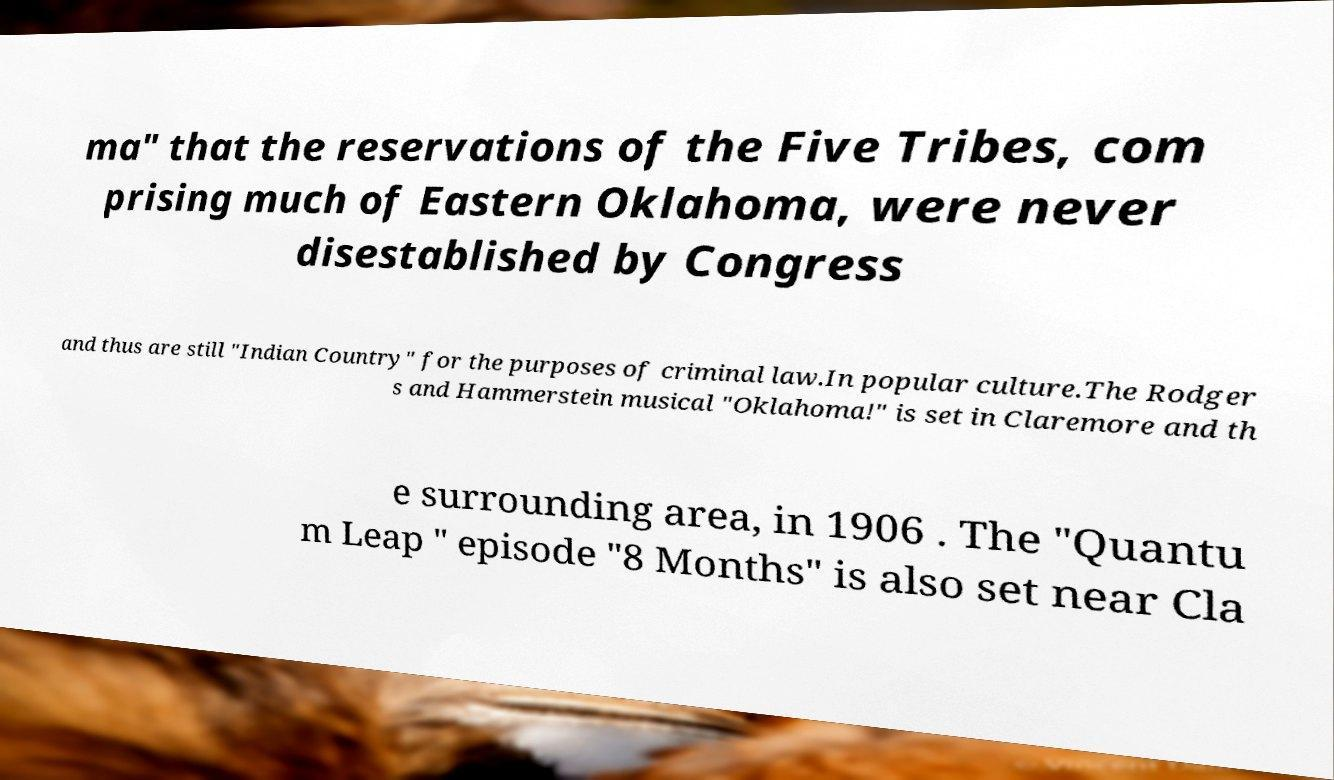Please read and relay the text visible in this image. What does it say? ma" that the reservations of the Five Tribes, com prising much of Eastern Oklahoma, were never disestablished by Congress and thus are still "Indian Country" for the purposes of criminal law.In popular culture.The Rodger s and Hammerstein musical "Oklahoma!" is set in Claremore and th e surrounding area, in 1906 . The "Quantu m Leap " episode "8 Months" is also set near Cla 